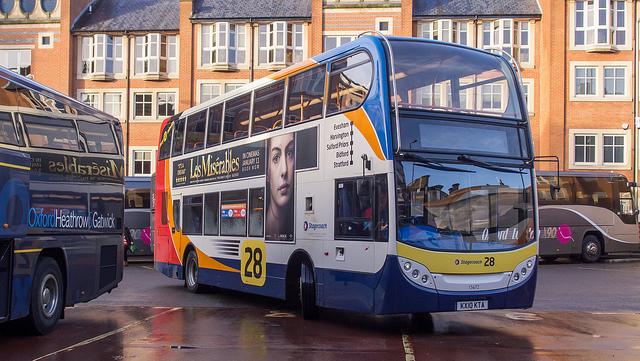What number is on the side of the bus?
Be succinct. 28. What movie is advertised?
Be succinct. Les miserables. Are these buses the same design style?
Write a very short answer. No. What number is the bus on the right?
Answer briefly. 28. Is the famous play/movie depicted about buoyantly, happy people?
Give a very brief answer. No. 